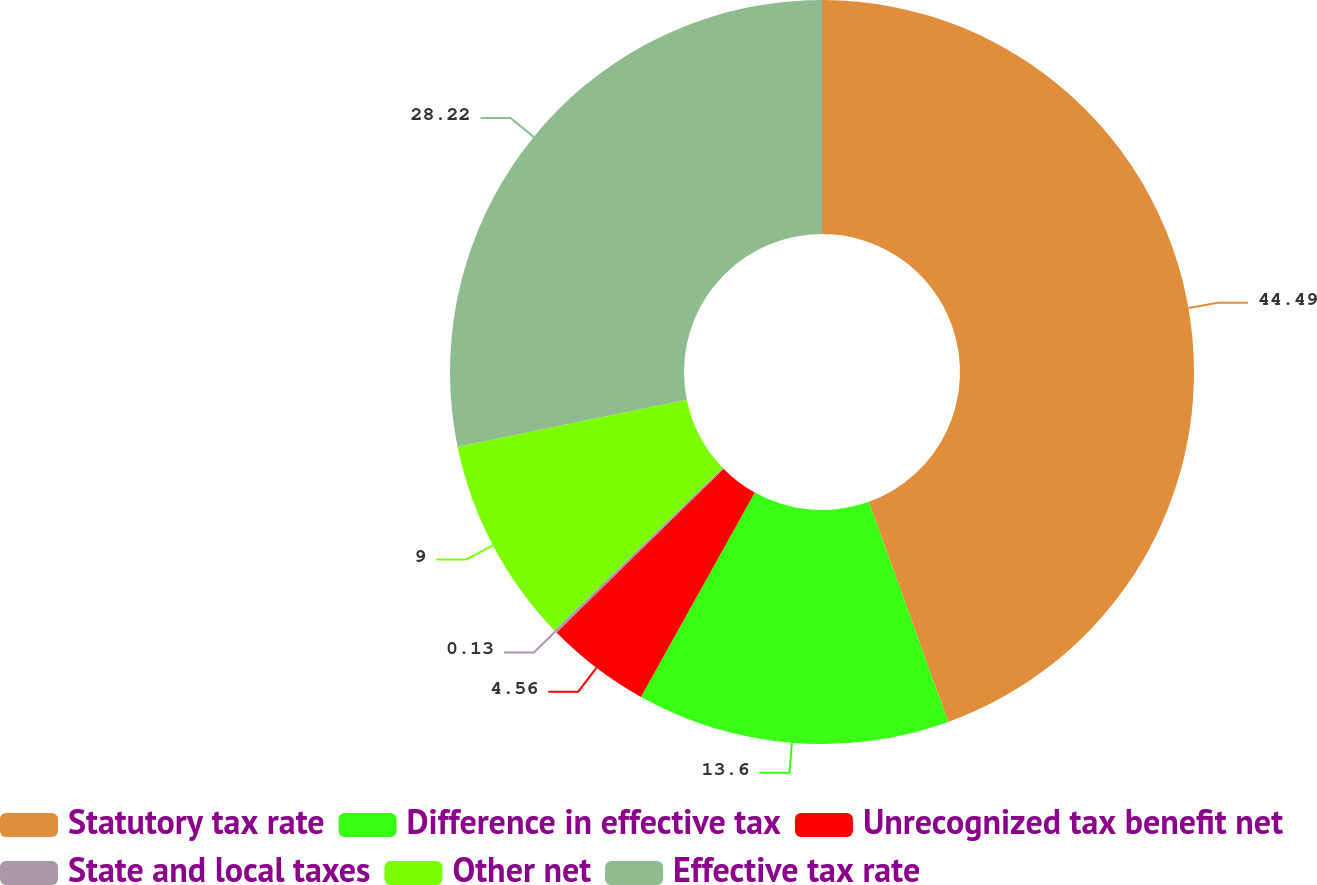Convert chart. <chart><loc_0><loc_0><loc_500><loc_500><pie_chart><fcel>Statutory tax rate<fcel>Difference in effective tax<fcel>Unrecognized tax benefit net<fcel>State and local taxes<fcel>Other net<fcel>Effective tax rate<nl><fcel>44.49%<fcel>13.6%<fcel>4.56%<fcel>0.13%<fcel>9.0%<fcel>28.22%<nl></chart> 